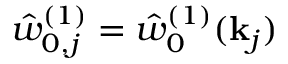<formula> <loc_0><loc_0><loc_500><loc_500>\hat { w } _ { 0 , j } ^ { ( 1 ) } = \hat { w } _ { 0 } ^ { ( 1 ) } ( k _ { j } )</formula> 